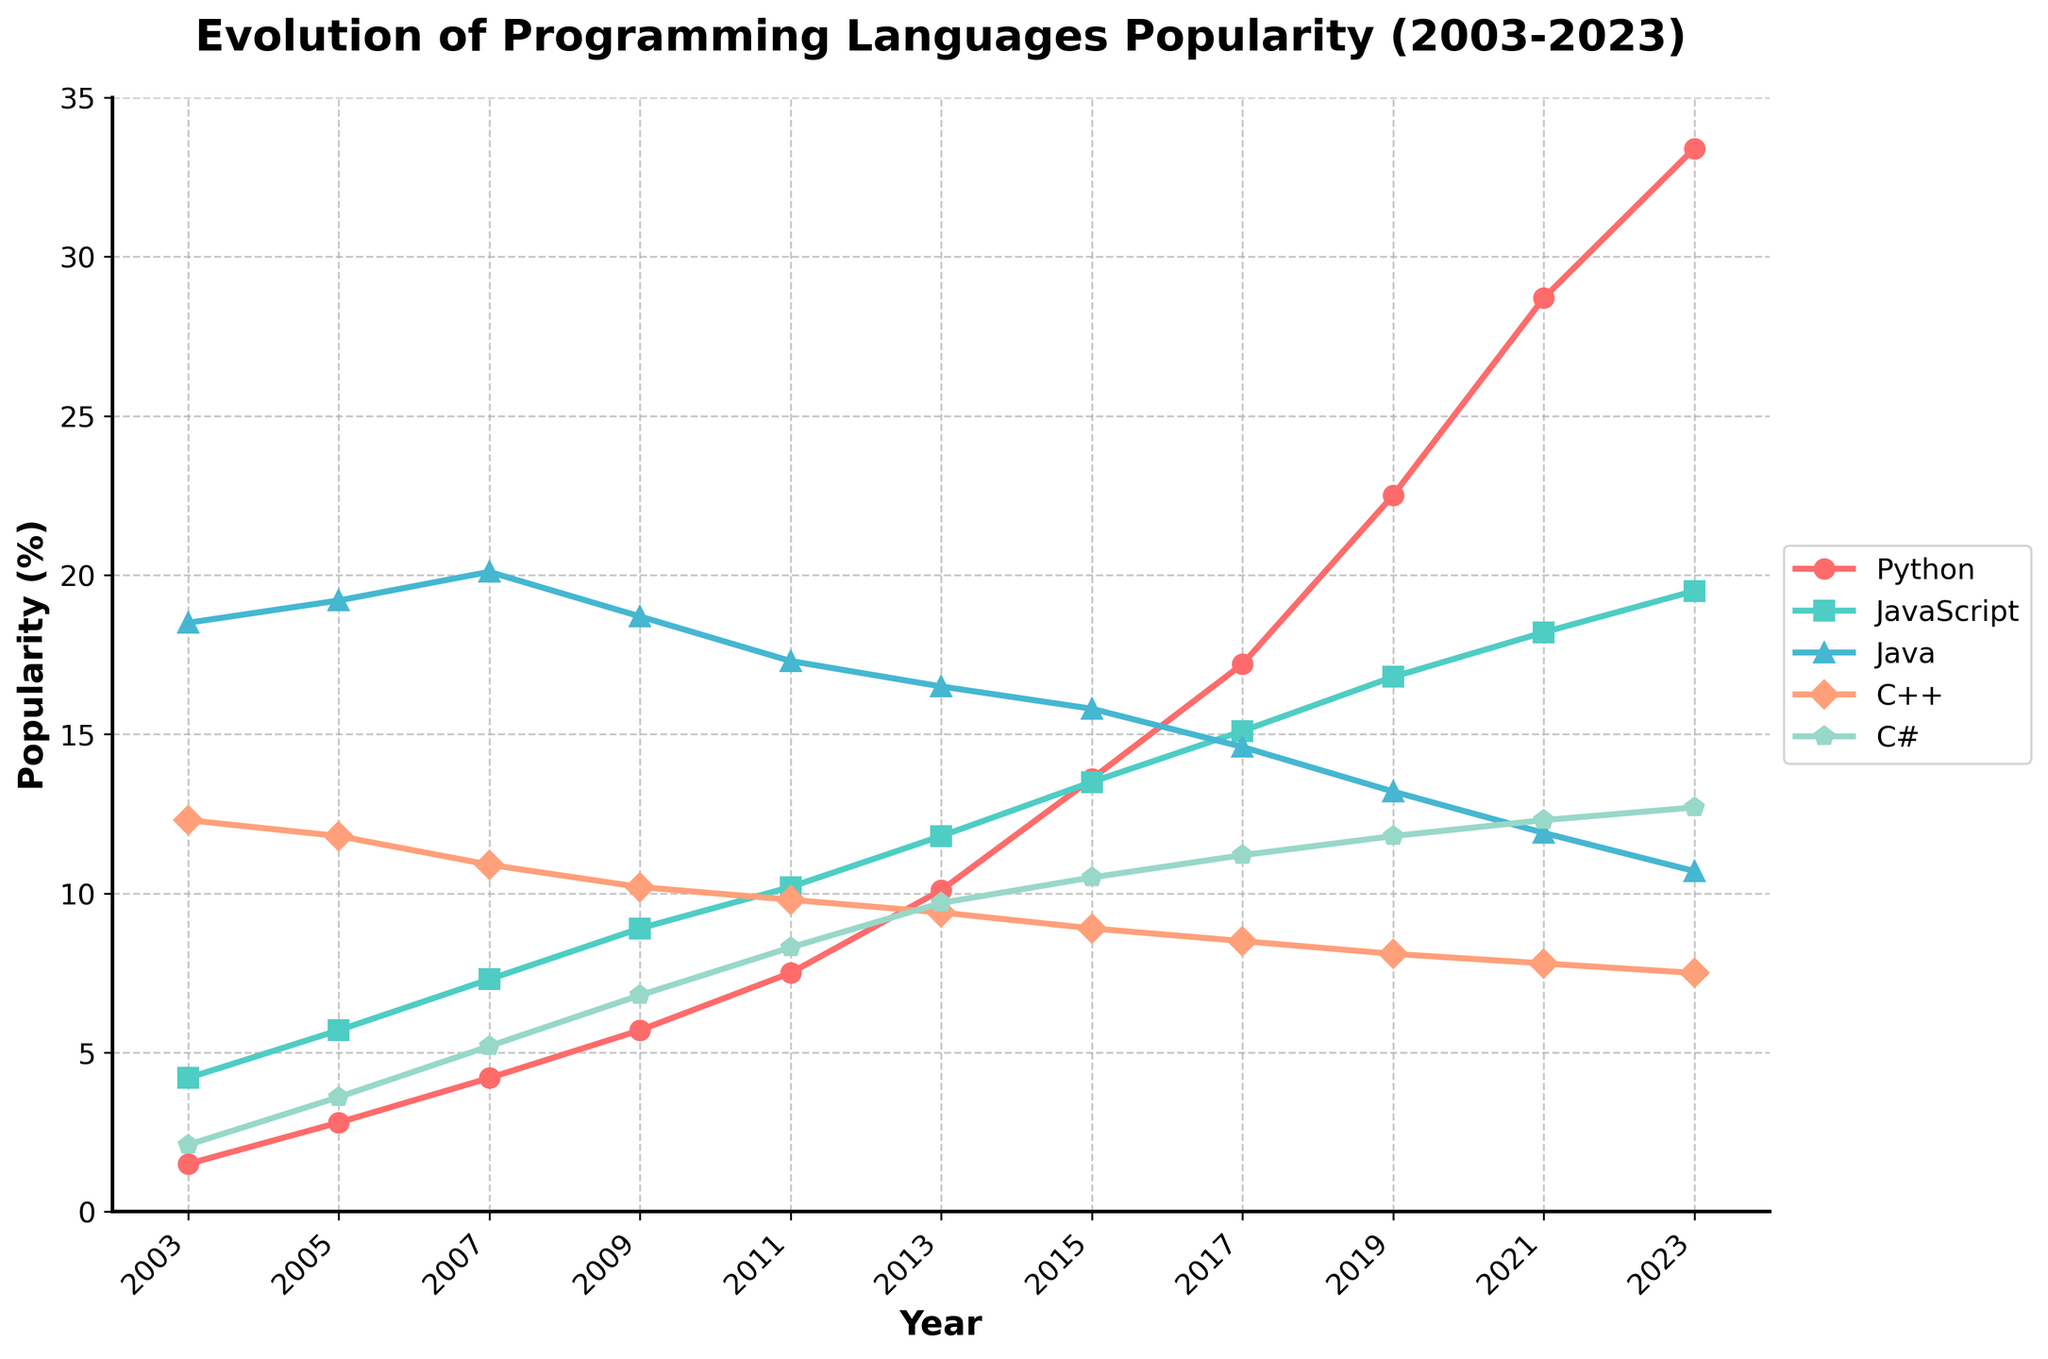Which programming language shows the highest increase in popularity over the 20 years? To find the language with the highest increase, look at the difference between the 2023 value and the 2003 value for each language. Python increased from 1.5 to 33.4 (31.9), JavaScript from 4.2 to 19.5 (15.3), Java from 18.5 to 10.7 (-7.8), C++ from 12.3 to 7.5 (-4.8), and C# from 2.1 to 12.7 (10.6). Python shows the highest increase.
Answer: Python Which language had more popularity in 2005, JavaScript or C++? To determine which language was more popular in 2005, compare their values. JavaScript had a popularity of 5.7%, while C++ had 11.8%. Therefore, C++ was more popular in 2005.
Answer: C++ By how much did Python's popularity increase from 2019 to 2023? Calculate the difference between the 2023 and 2019 values for Python. Python's popularity in 2019 was 22.5% and in 2023 was 33.4%. The increase is 33.4 - 22.5 = 10.9.
Answer: 10.9 Which language had the smallest increase in popularity between 2003 and 2023? To find the language with the smallest increase, calculate the difference for each. Python: 31.9, JavaScript: 15.3, Java: -7.8, C++: -4.8, C#: 10.6. Java had the smallest increase (actually, it decreased).
Answer: Java Compare the popularity of Python and JavaScript in 2023 and determine the difference. Python's popularity in 2023 is 33.4%, and JavaScript's is 19.5%. The difference is 33.4 - 19.5 = 13.9.
Answer: 13.9 In which year did Java have its highest popularity within the given period? Observe the plot for Java's trend and identify the highest peak. Java's highest value was in 2007 at 20.1%.
Answer: 2007 What is the average popularity of C++ from 2003 to 2023? To compute the average, sum all the values from 2003 to 2023 and divide by the number of years. The values for C++ are [12.3, 11.8, 10.9, 10.2, 9.8, 9.4, 8.9, 8.5, 8.1, 7.8, 7.5]; the sum is 104.2 and there are 11 data points. The average is 104.2 / 11 ≈ 9.47.
Answer: ~9.47 Which language showed the most consistent growth over the years? Analyze the plot's trends for each language. Python shows a steady and consistent upward trend without any major decreases.
Answer: Python How did C#'s popularity change from 2011 to 2017? Check the values of C# for 2011 and 2017. C# had a popularity of 8.3% in 2011 and 11.2% in 2017. The increase is 11.2 - 8.3 = 2.9.
Answer: 2.9 Which languages' popularity intersected at any point between 2003 and 2023, and in which year(s)? By visually inspecting the plot, we can see if the lines intersect. Python and JavaScript intersected around the year 2013.
Answer: 2013 